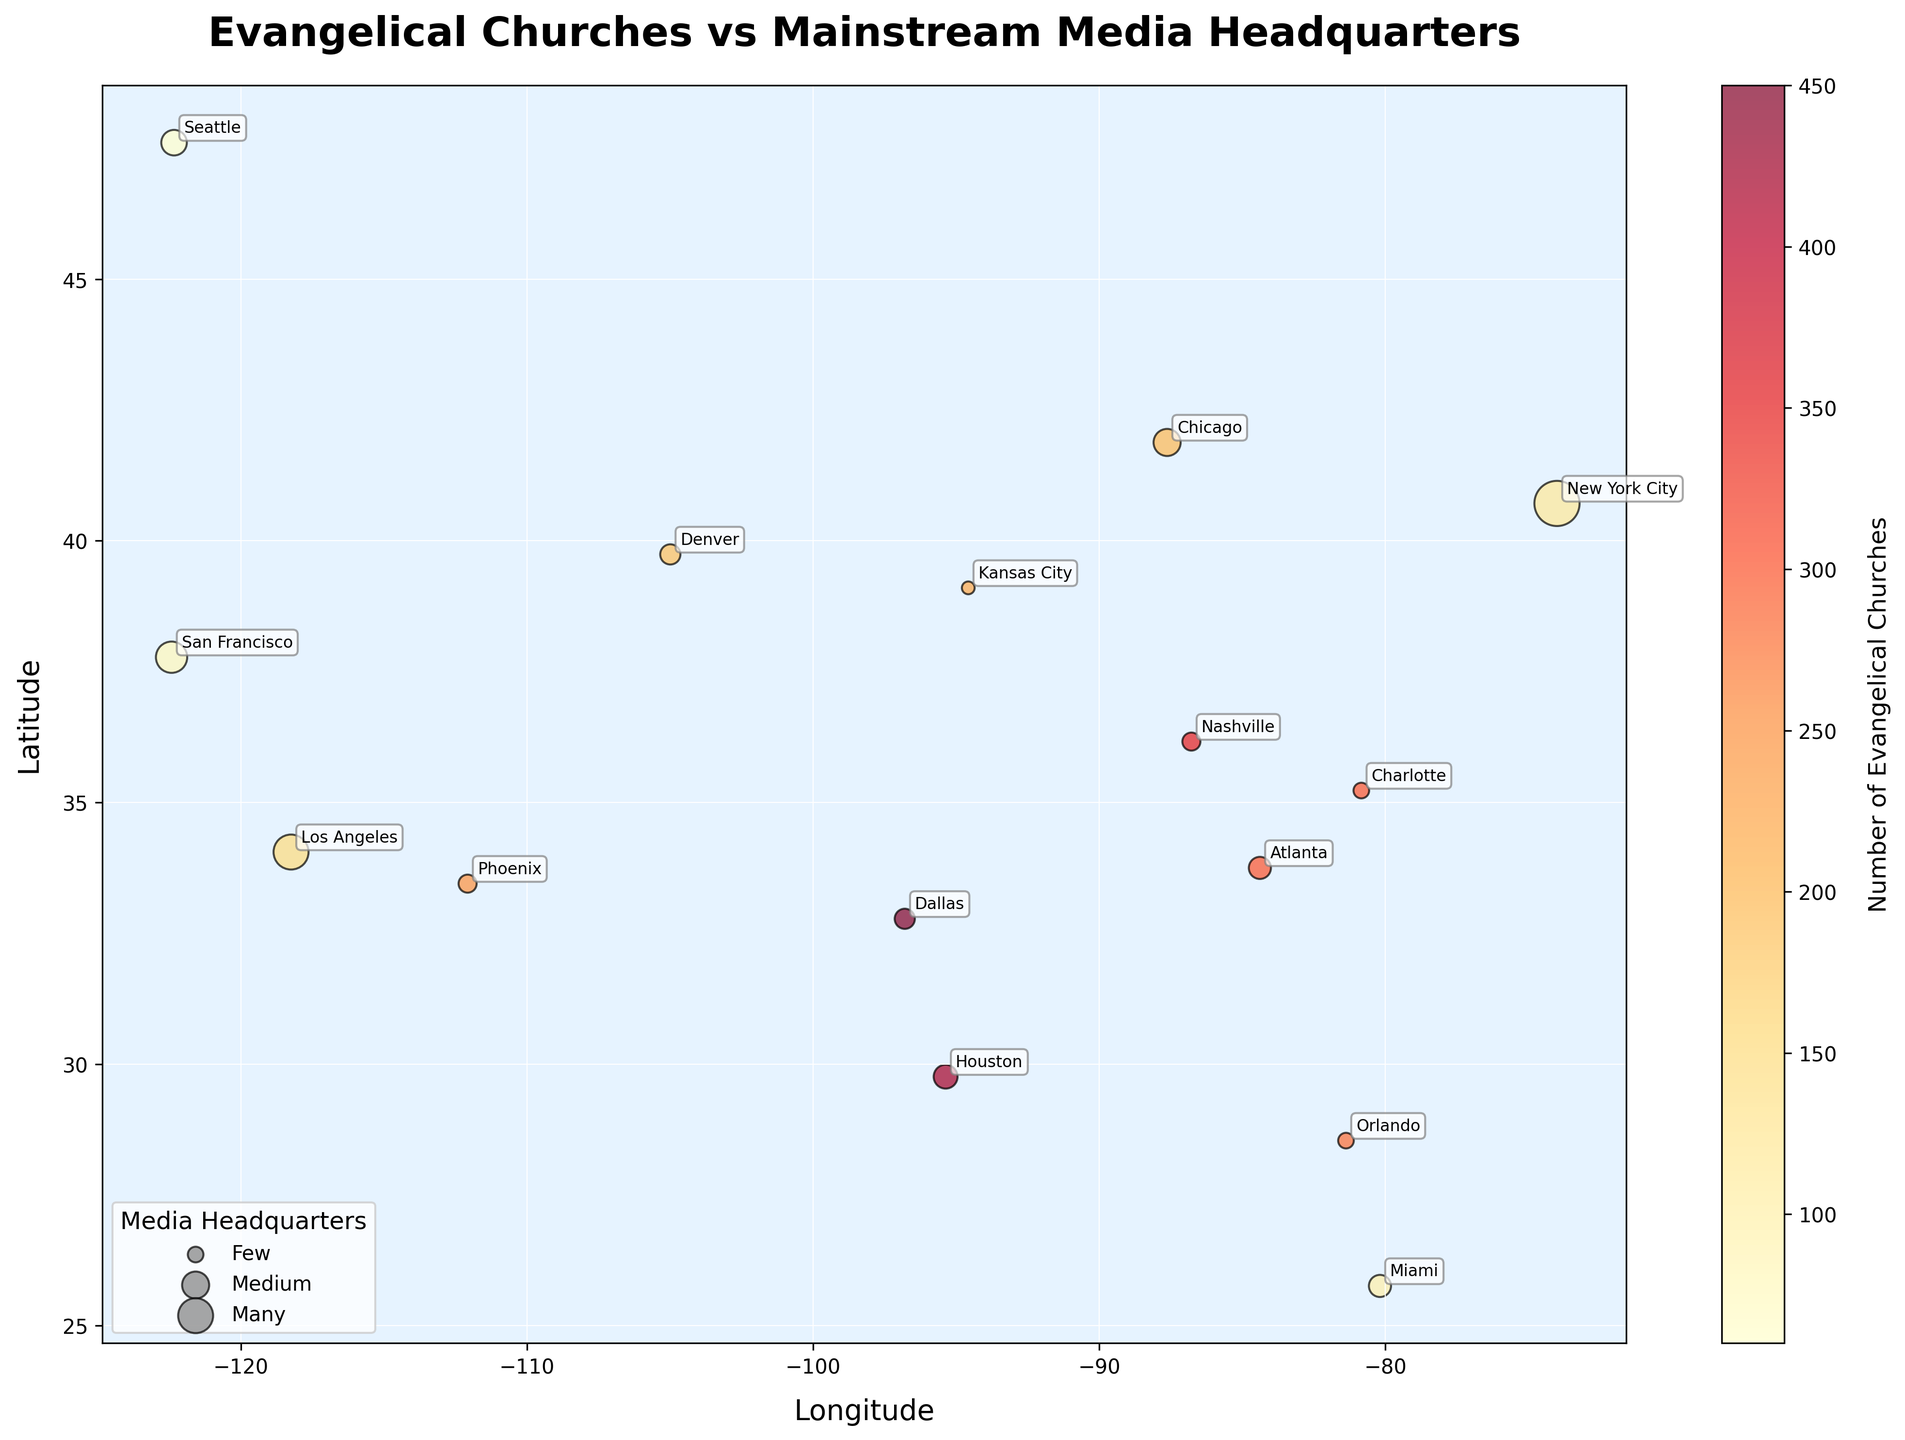What is the title of the heatmap? The title is typically displayed at the top of the heatmap. In this case, it reads "Evangelical Churches vs Mainstream Media Headquarters". This title succinctly tells us the main focus of the data being visualized.
Answer: Evangelical Churches vs Mainstream Media Headquarters Which location has the highest number of evangelical churches according to the heatmap? By examining the color intensity on the heatmap, we can see that Dallas, with 450 churches, has the highest number of evangelical churches.
Answer: Dallas What does the size of the dots represent in the heatmap? The legend indicates that the size of the dots corresponds to the number of mainstream media headquarters. Larger dots represent cities with more media headquarters.
Answer: Number of mainstream media headquarters Which city has a significant number of both evangelical churches and mainstream media headquarters? Looking at both the color (indicating churches) and size of the dots (indicating media headquarters), Los Angeles stands out with 150 churches and 15 headquarters.
Answer: Los Angeles Compare the number of evangelical churches in Dallas and New York City. How much greater is the number in Dallas? Dallas has 450 evangelical churches, while New York City has 120. The difference is (450 - 120) = 330 churches.
Answer: 330 Which city has the fewest evangelical churches, and how many does it have? By looking at the color scale, Seattle has the lightest shade, indicating it has the fewest evangelical churches, which is 60.
Answer: Seattle Among the cities shown, which one has the highest number of mainstream media headquarters? The size of the dots indicates the number of media headquarters, and New York City has the largest dot, with 25 headquarters.
Answer: New York City What's the average number of evangelical churches in Atlanta, Phoenix, and Orlando? Sum the number of churches in Atlanta (300), Phoenix (250), and Orlando (280), then divide by 3: (300 + 250 + 280) / 3 = 830 / 3.
Answer: 276.67 How many cities have more than 200 evangelical churches according to the heatmap? By identifying the cities with darker shades indicative of higher numbers, we find that 6 cities (Dallas, Atlanta, Nashville, Houston, Phoenix, Charlotte) have more than 200 churches.
Answer: 6 Which city has nearly equal numbers of evangelical churches and mainstream media headquarters? Adding the dots to our inspection, Miami has a close number with 100 evangelical churches and 6 mainstream media headquarters. This city has relatively balanced numbers compared to others.
Answer: Miami 